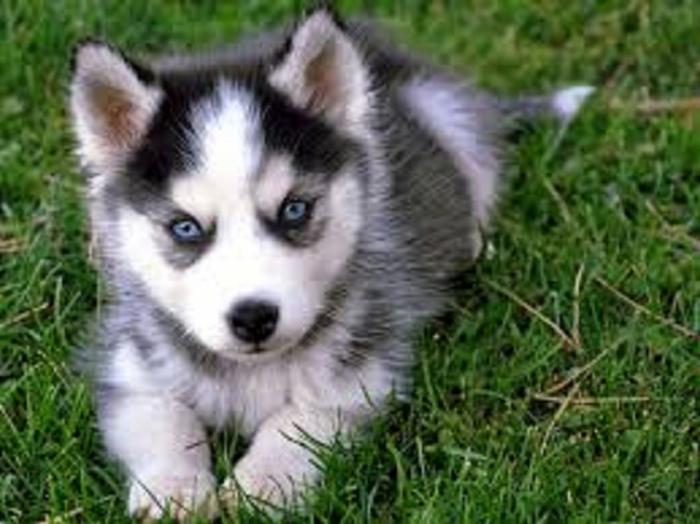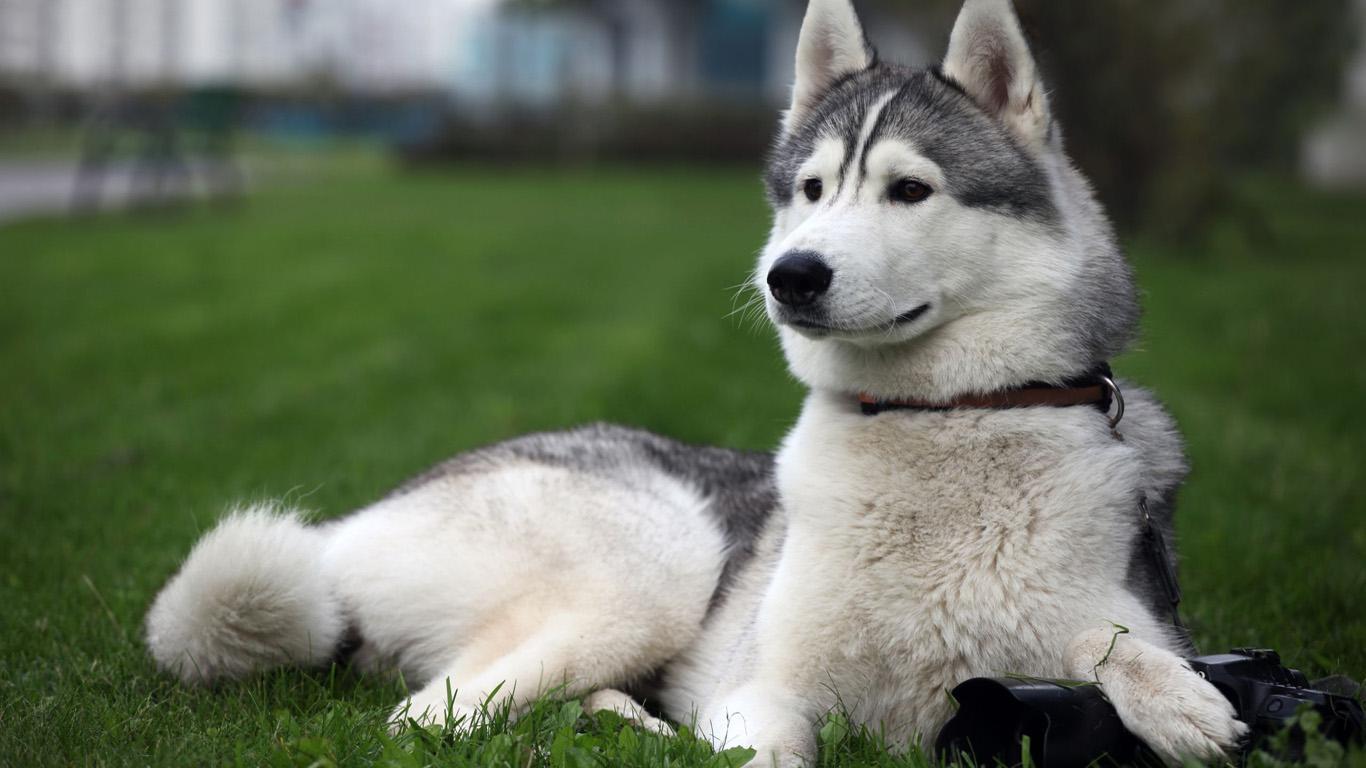The first image is the image on the left, the second image is the image on the right. Given the left and right images, does the statement "The left and right image contains the same number of dogs with one puppy and one adult." hold true? Answer yes or no. Yes. 